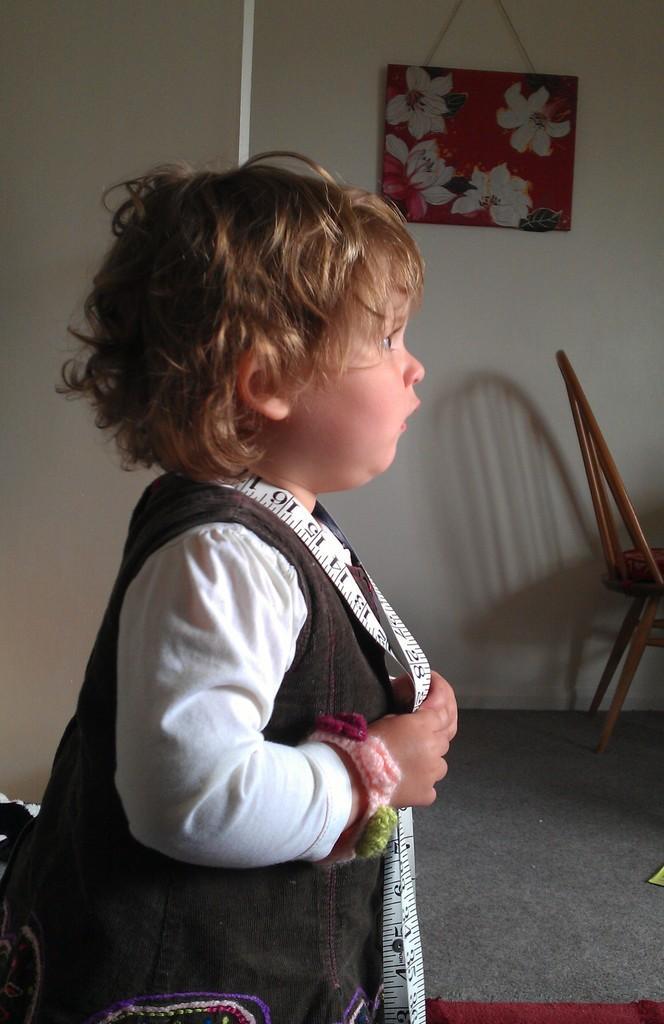How would you summarize this image in a sentence or two? There is a baby standing and holding a measuring tape in her hand. 